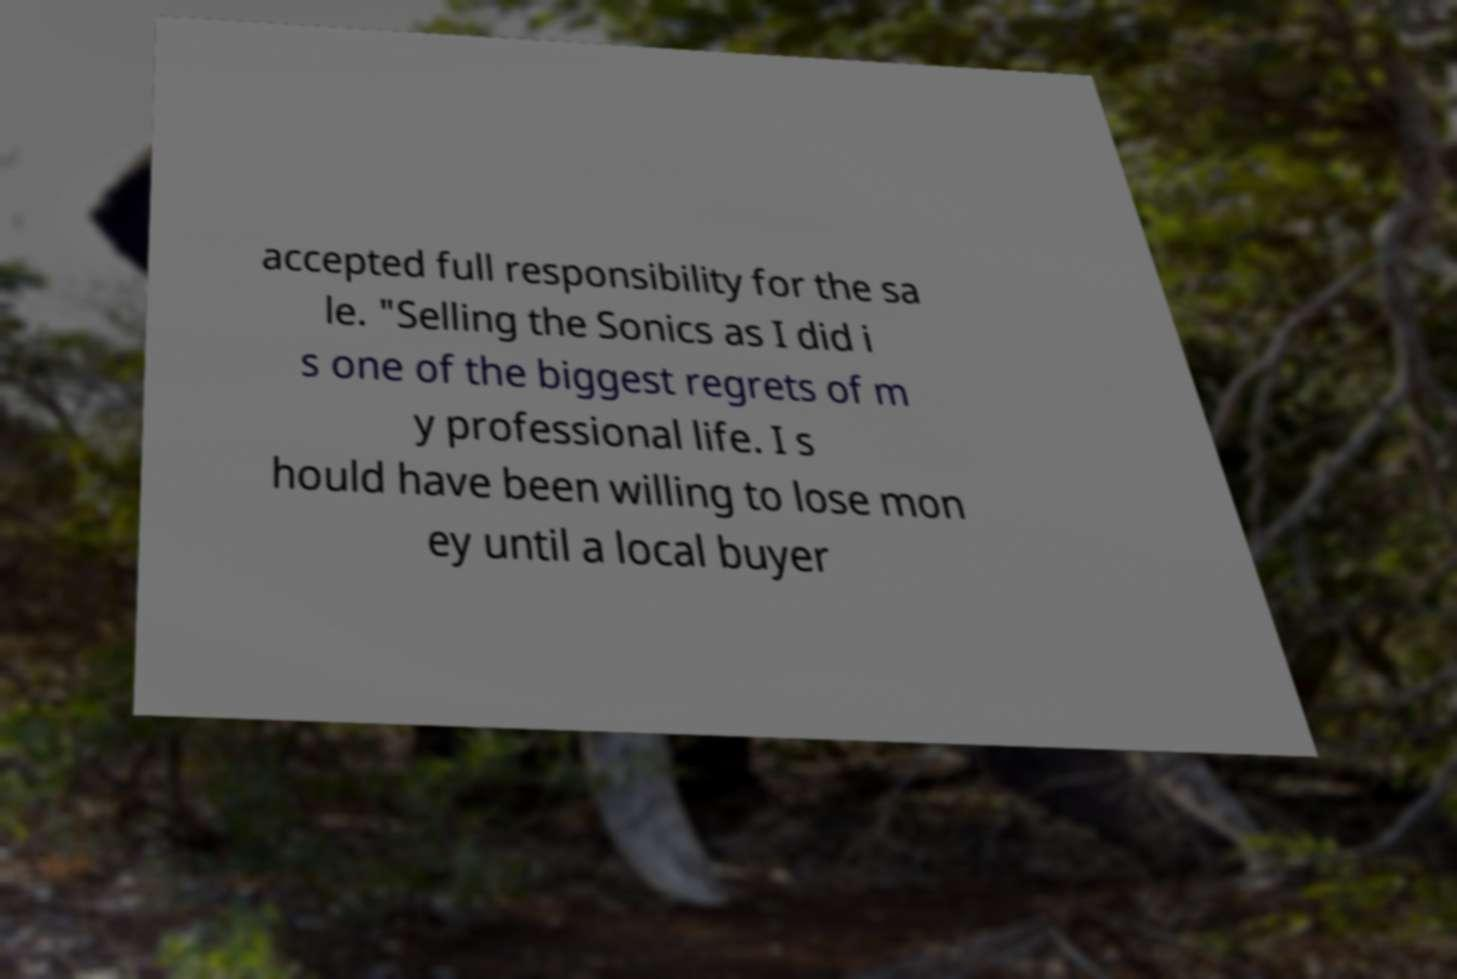For documentation purposes, I need the text within this image transcribed. Could you provide that? accepted full responsibility for the sa le. "Selling the Sonics as I did i s one of the biggest regrets of m y professional life. I s hould have been willing to lose mon ey until a local buyer 